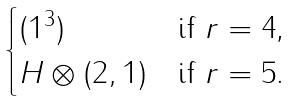Convert formula to latex. <formula><loc_0><loc_0><loc_500><loc_500>\begin{cases} ( 1 ^ { 3 } ) & \text {if $r=4$,} \\ H \otimes ( 2 , 1 ) & \text {if $r=5$.} \end{cases}</formula> 